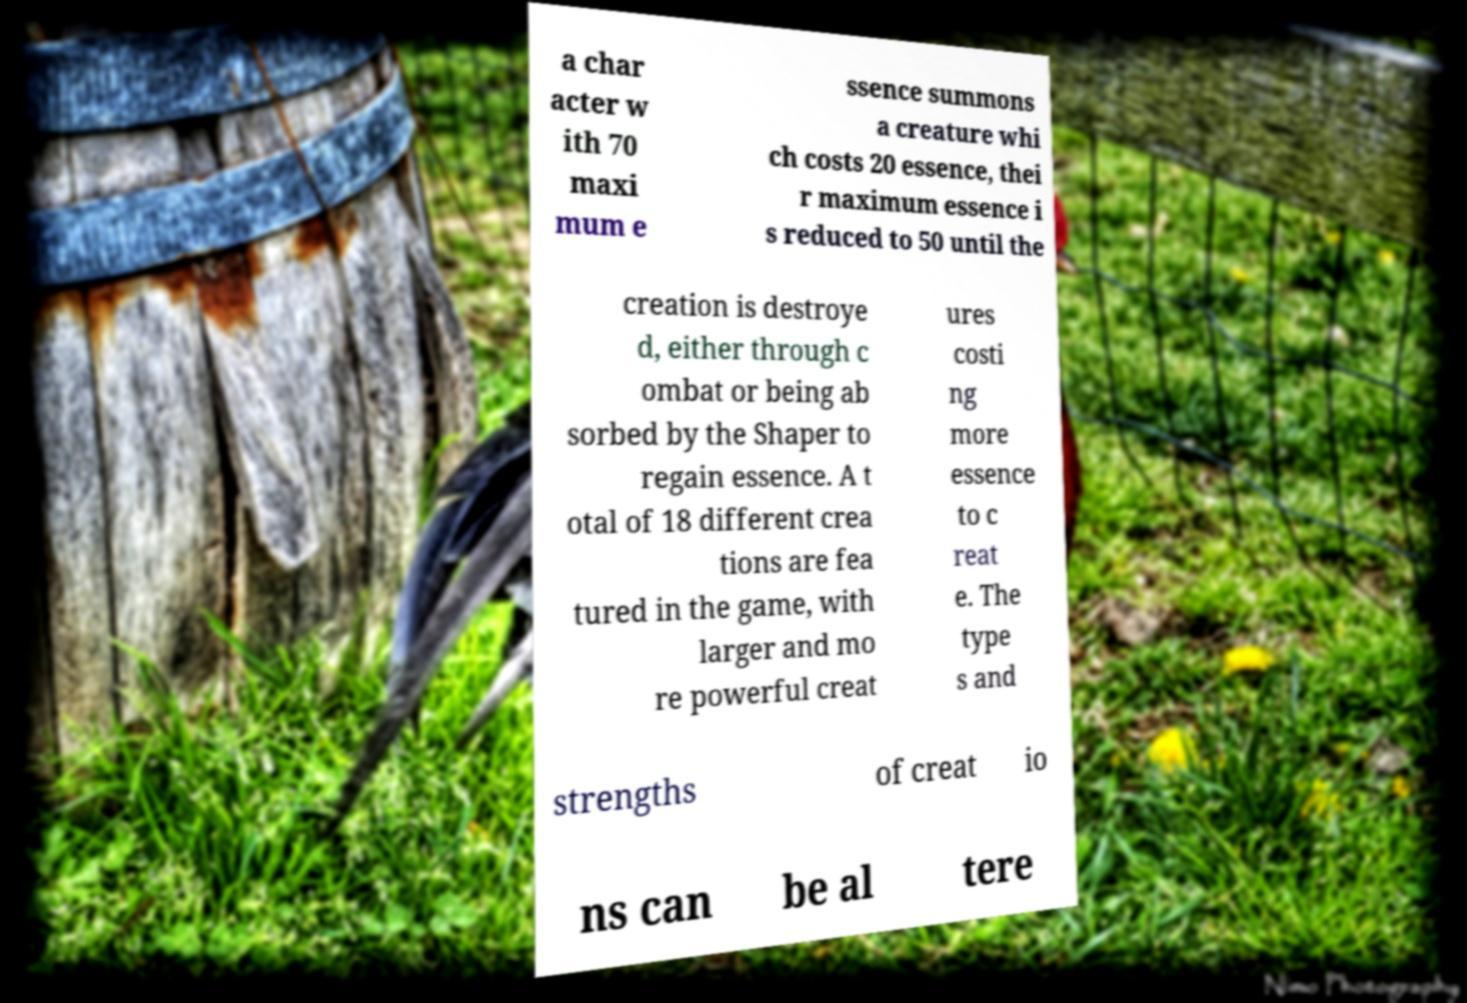What messages or text are displayed in this image? I need them in a readable, typed format. a char acter w ith 70 maxi mum e ssence summons a creature whi ch costs 20 essence, thei r maximum essence i s reduced to 50 until the creation is destroye d, either through c ombat or being ab sorbed by the Shaper to regain essence. A t otal of 18 different crea tions are fea tured in the game, with larger and mo re powerful creat ures costi ng more essence to c reat e. The type s and strengths of creat io ns can be al tere 